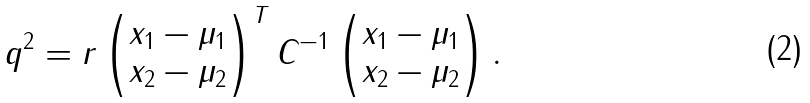<formula> <loc_0><loc_0><loc_500><loc_500>q ^ { 2 } = r \begin{pmatrix} x _ { 1 } - \mu _ { 1 } \\ x _ { 2 } - \mu _ { 2 } \end{pmatrix} ^ { T } C ^ { - 1 } \begin{pmatrix} x _ { 1 } - \mu _ { 1 } \\ x _ { 2 } - \mu _ { 2 } \end{pmatrix} .</formula> 